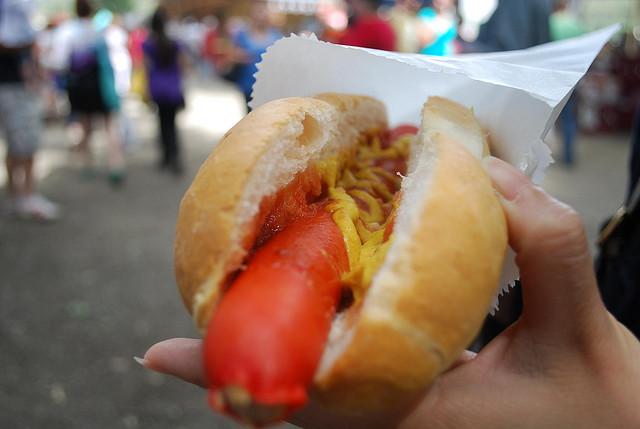Is this food tasty?
Write a very short answer. Yes. What kind of food is this?
Answer briefly. Hot dog. Is this a jumbo hot dog?
Write a very short answer. Yes. Is the hot dog topped with pickles?
Answer briefly. No. 